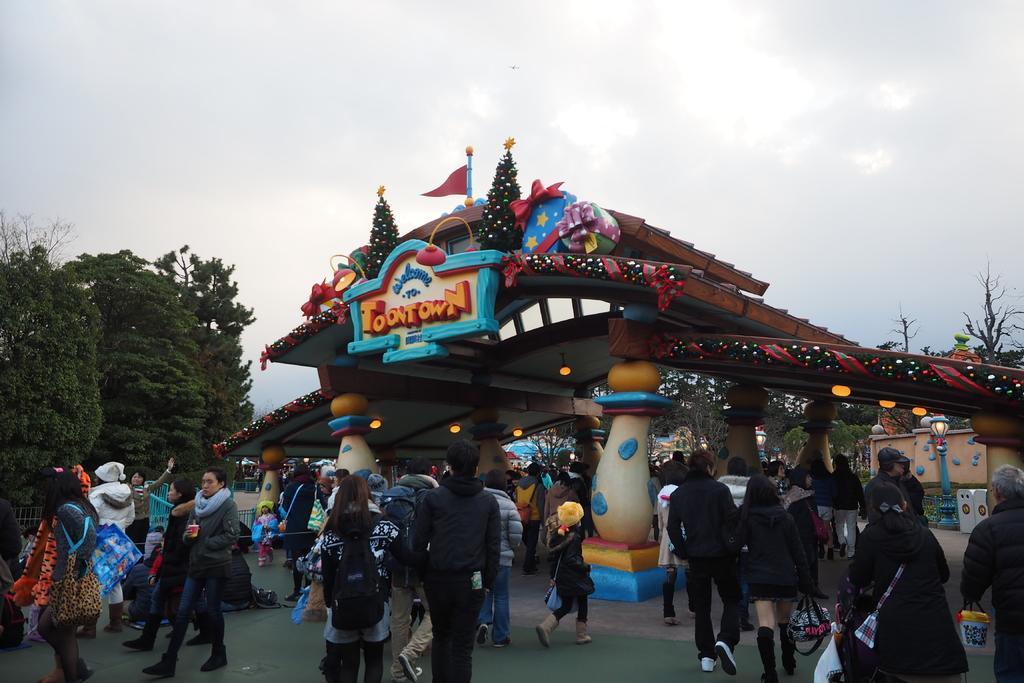How would you summarize this image in a sentence or two? In this image I can see number of persons are standing on the ground and few of them are sitting on the ground. In the background I can see the arch which is brown, red, pink, blue and green in color and I can see a flag on the arch. I can see few trees, the wall and the sky in the background. 